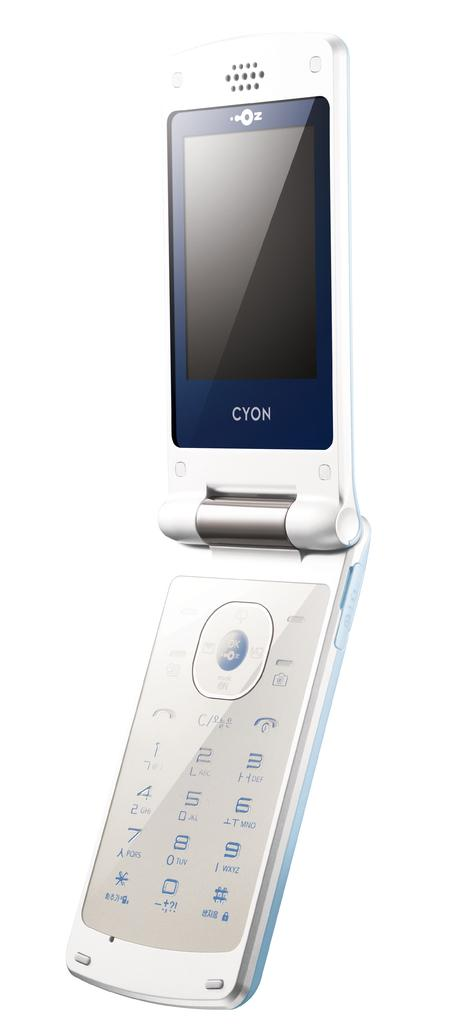Provide a one-sentence caption for the provided image. A Cyon flip phone is displayed open against a white background. 